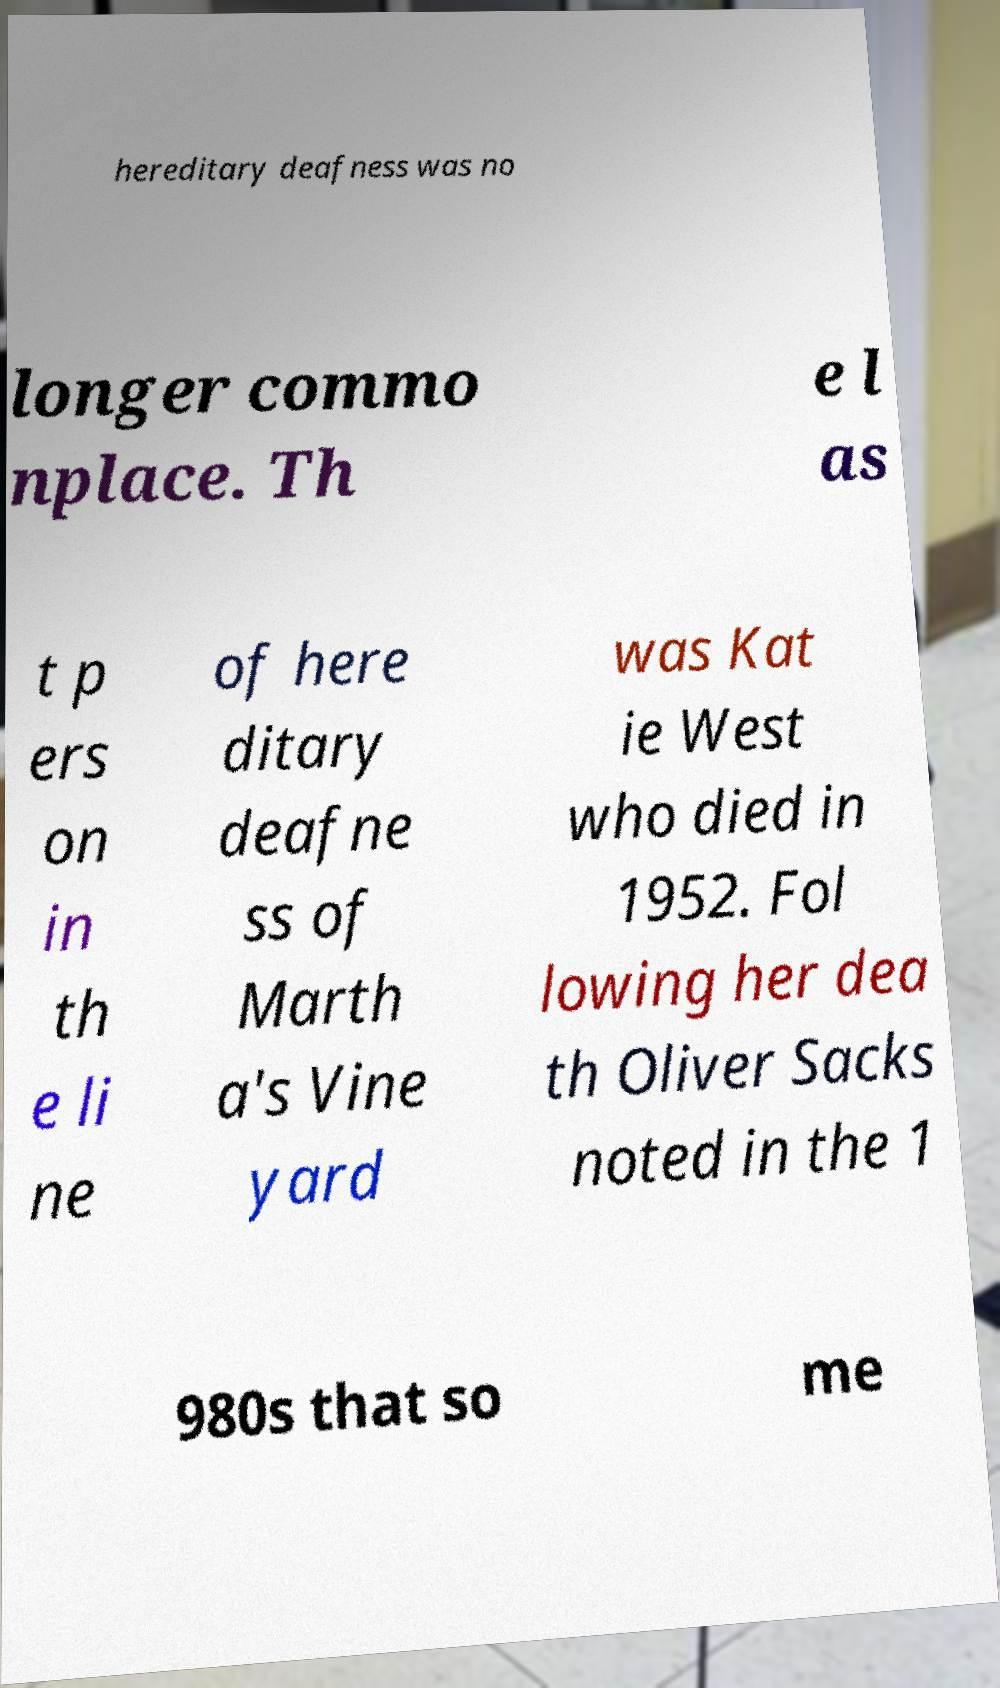Can you read and provide the text displayed in the image?This photo seems to have some interesting text. Can you extract and type it out for me? hereditary deafness was no longer commo nplace. Th e l as t p ers on in th e li ne of here ditary deafne ss of Marth a's Vine yard was Kat ie West who died in 1952. Fol lowing her dea th Oliver Sacks noted in the 1 980s that so me 